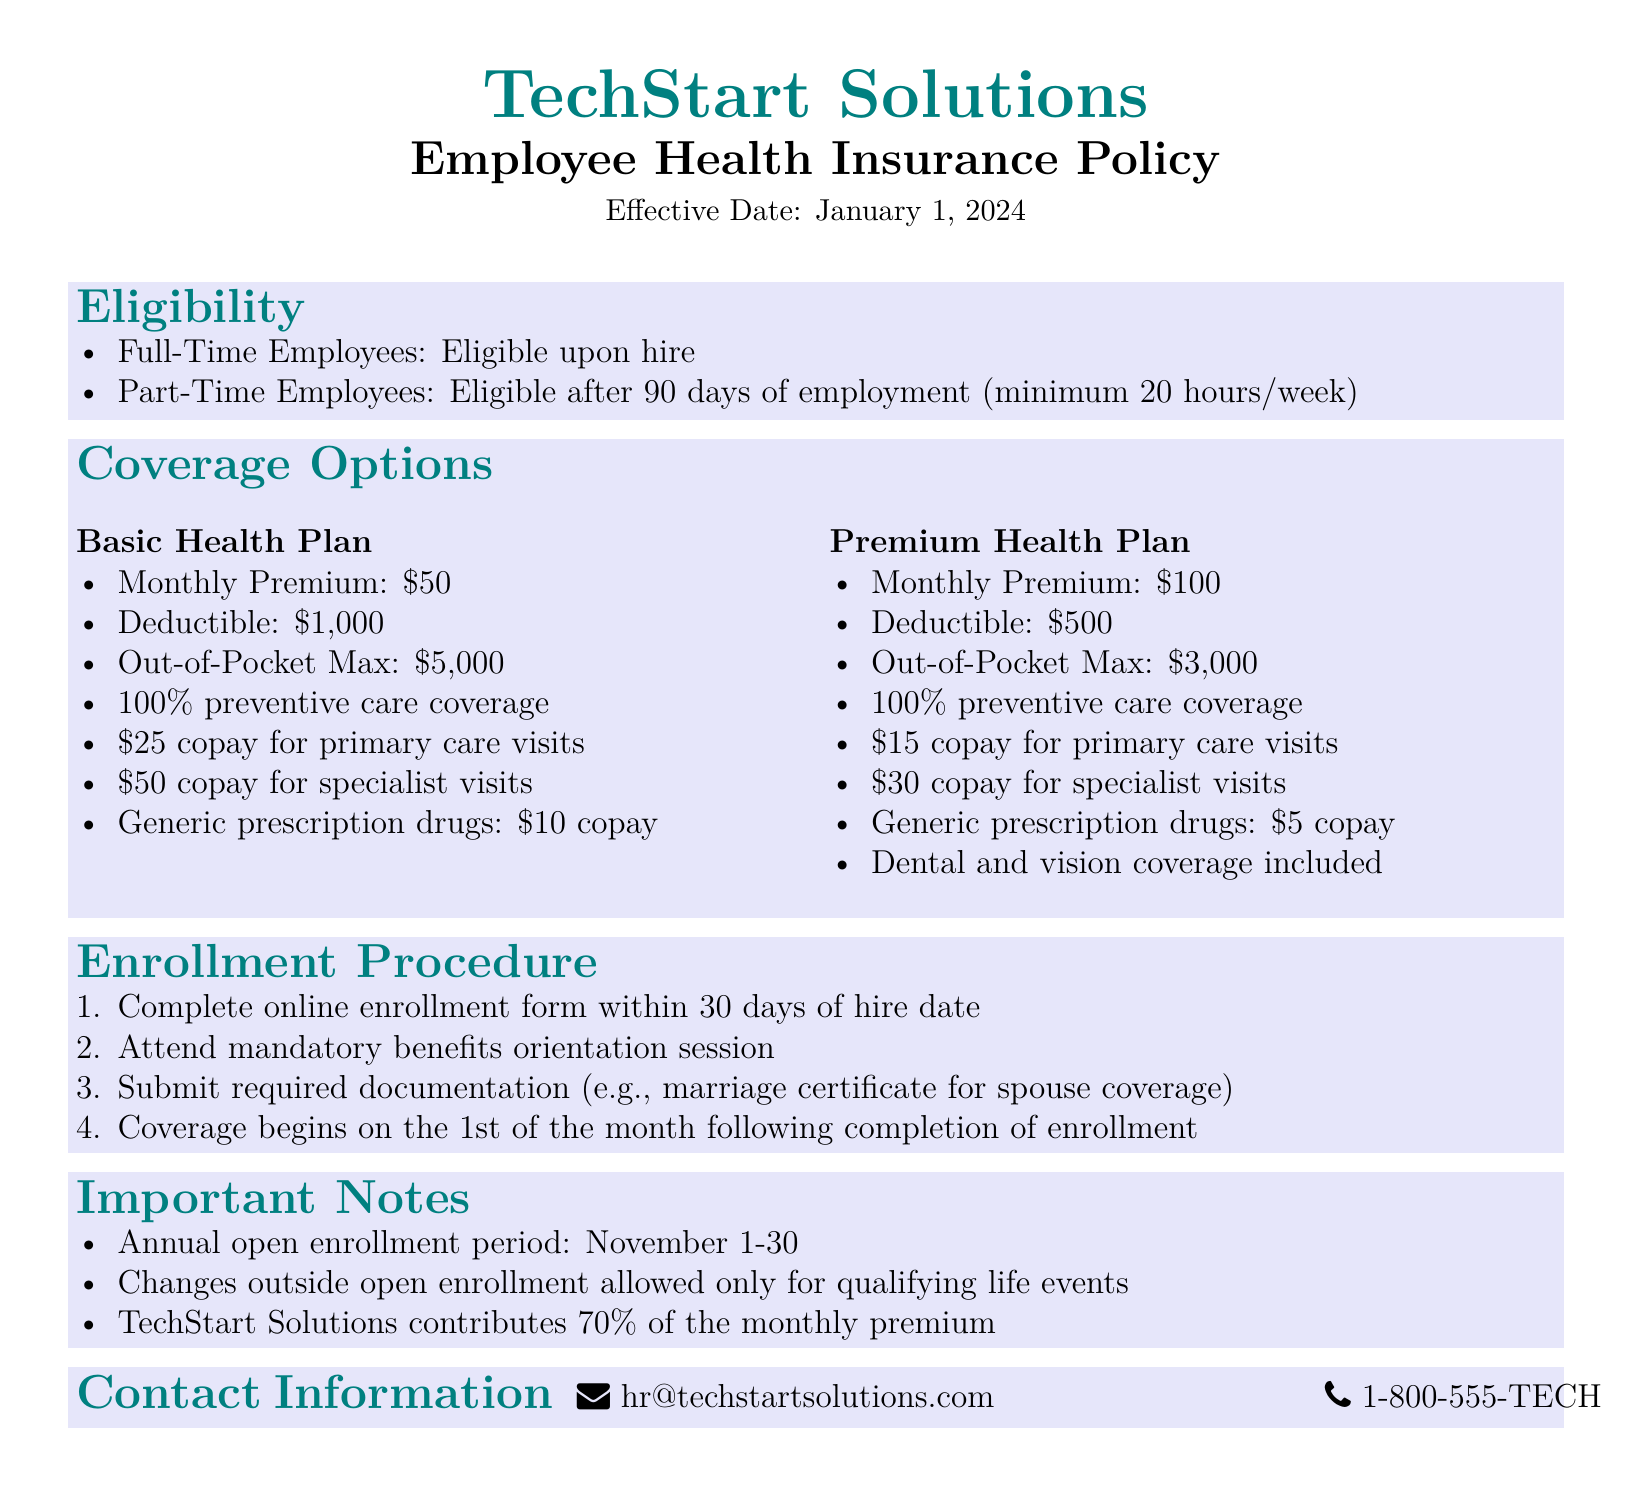What is the effective date of the policy? The effective date is stated at the top of the document.
Answer: January 1, 2024 Who is eligible for health insurance upon hire? Eligibility section specifies who is covered immediately.
Answer: Full-Time Employees What is the monthly premium for the Basic Health Plan? This information is found in the Coverage Options section under Basic Health Plan.
Answer: $50 What is the deductible for the Premium Health Plan? The deductible amount for the Premium Health Plan is listed in the Coverage Options section.
Answer: $500 What must be submitted for spouse coverage? The Enrollment Procedure outlines required documentation for spouse coverage.
Answer: Marriage certificate What is the out-of-pocket maximum for the Basic Health Plan? This is a specific figure provided in the Coverage Options for the Basic Health Plan.
Answer: $5,000 When does coverage begin after enrollment? This detail is included in the Enrollment Procedure section of the document.
Answer: On the 1st of the month following completion of enrollment How much does TechStart Solutions contribute to premiums? Important Notes section specifically mentions the contribution percentage.
Answer: 70% What is the open enrollment period? The specified period is indicated in the Important Notes section.
Answer: November 1-30 